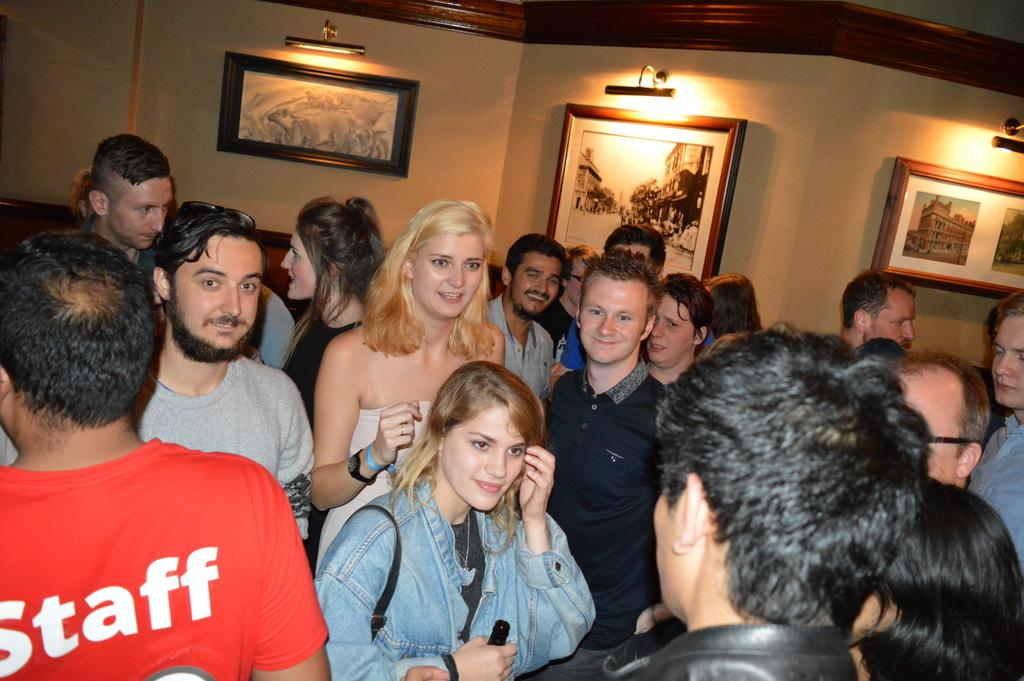Who or what can be seen in the image? There are people in the image. What is visible in the background of the image? There is a wall and lights in the background of the image. What is placed on the wall? Photo frames are placed on the wall. How many people are crying in the image? There is no indication in the image that anyone is crying, so it cannot be determined from the picture. 